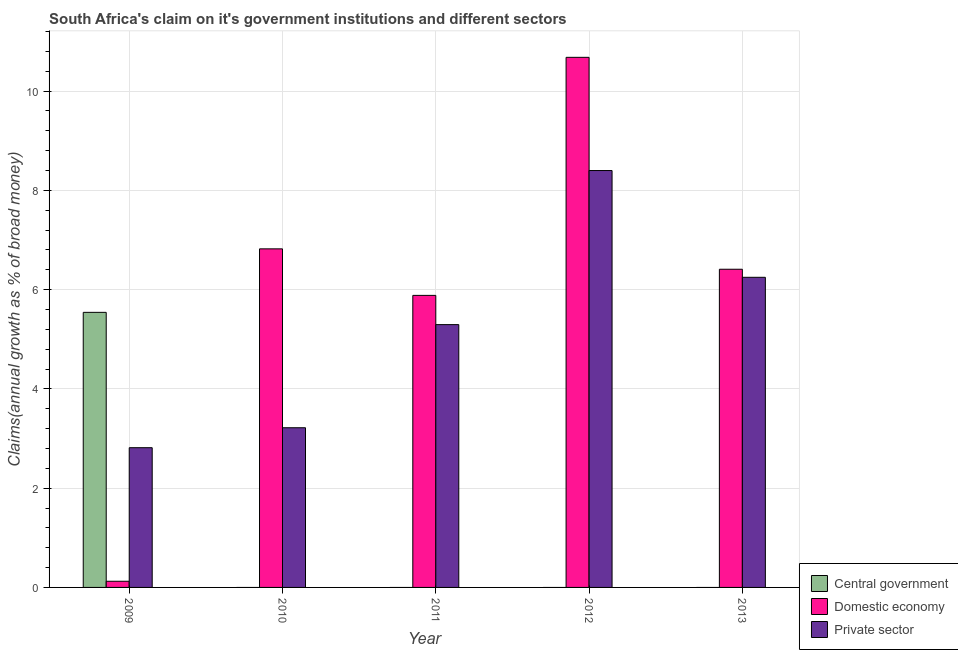How many groups of bars are there?
Your answer should be compact. 5. Are the number of bars per tick equal to the number of legend labels?
Keep it short and to the point. No. What is the label of the 5th group of bars from the left?
Keep it short and to the point. 2013. In how many cases, is the number of bars for a given year not equal to the number of legend labels?
Offer a terse response. 4. What is the percentage of claim on the domestic economy in 2012?
Keep it short and to the point. 10.68. Across all years, what is the maximum percentage of claim on the domestic economy?
Provide a succinct answer. 10.68. In which year was the percentage of claim on the private sector maximum?
Keep it short and to the point. 2012. What is the total percentage of claim on the private sector in the graph?
Offer a terse response. 25.97. What is the difference between the percentage of claim on the private sector in 2009 and that in 2012?
Your response must be concise. -5.58. What is the difference between the percentage of claim on the central government in 2013 and the percentage of claim on the domestic economy in 2009?
Provide a short and direct response. -5.54. What is the average percentage of claim on the private sector per year?
Provide a short and direct response. 5.19. In the year 2010, what is the difference between the percentage of claim on the domestic economy and percentage of claim on the private sector?
Ensure brevity in your answer.  0. What is the ratio of the percentage of claim on the private sector in 2010 to that in 2013?
Provide a succinct answer. 0.51. What is the difference between the highest and the second highest percentage of claim on the domestic economy?
Ensure brevity in your answer.  3.86. What is the difference between the highest and the lowest percentage of claim on the central government?
Provide a succinct answer. 5.54. Is it the case that in every year, the sum of the percentage of claim on the central government and percentage of claim on the domestic economy is greater than the percentage of claim on the private sector?
Keep it short and to the point. Yes. How many bars are there?
Keep it short and to the point. 11. How many years are there in the graph?
Your answer should be compact. 5. What is the difference between two consecutive major ticks on the Y-axis?
Your answer should be very brief. 2. Where does the legend appear in the graph?
Your answer should be very brief. Bottom right. How many legend labels are there?
Ensure brevity in your answer.  3. What is the title of the graph?
Keep it short and to the point. South Africa's claim on it's government institutions and different sectors. What is the label or title of the X-axis?
Your answer should be compact. Year. What is the label or title of the Y-axis?
Provide a short and direct response. Claims(annual growth as % of broad money). What is the Claims(annual growth as % of broad money) in Central government in 2009?
Keep it short and to the point. 5.54. What is the Claims(annual growth as % of broad money) in Domestic economy in 2009?
Offer a very short reply. 0.12. What is the Claims(annual growth as % of broad money) of Private sector in 2009?
Provide a short and direct response. 2.82. What is the Claims(annual growth as % of broad money) in Central government in 2010?
Make the answer very short. 0. What is the Claims(annual growth as % of broad money) of Domestic economy in 2010?
Provide a short and direct response. 6.82. What is the Claims(annual growth as % of broad money) in Private sector in 2010?
Your answer should be compact. 3.22. What is the Claims(annual growth as % of broad money) of Central government in 2011?
Provide a succinct answer. 0. What is the Claims(annual growth as % of broad money) of Domestic economy in 2011?
Ensure brevity in your answer.  5.88. What is the Claims(annual growth as % of broad money) in Private sector in 2011?
Your response must be concise. 5.29. What is the Claims(annual growth as % of broad money) of Central government in 2012?
Your response must be concise. 0. What is the Claims(annual growth as % of broad money) of Domestic economy in 2012?
Your answer should be compact. 10.68. What is the Claims(annual growth as % of broad money) of Private sector in 2012?
Offer a very short reply. 8.4. What is the Claims(annual growth as % of broad money) in Domestic economy in 2013?
Make the answer very short. 6.41. What is the Claims(annual growth as % of broad money) of Private sector in 2013?
Your answer should be compact. 6.25. Across all years, what is the maximum Claims(annual growth as % of broad money) in Central government?
Offer a very short reply. 5.54. Across all years, what is the maximum Claims(annual growth as % of broad money) in Domestic economy?
Your answer should be very brief. 10.68. Across all years, what is the maximum Claims(annual growth as % of broad money) in Private sector?
Your answer should be compact. 8.4. Across all years, what is the minimum Claims(annual growth as % of broad money) in Domestic economy?
Your response must be concise. 0.12. Across all years, what is the minimum Claims(annual growth as % of broad money) in Private sector?
Offer a terse response. 2.82. What is the total Claims(annual growth as % of broad money) in Central government in the graph?
Give a very brief answer. 5.54. What is the total Claims(annual growth as % of broad money) of Domestic economy in the graph?
Give a very brief answer. 29.92. What is the total Claims(annual growth as % of broad money) in Private sector in the graph?
Provide a succinct answer. 25.97. What is the difference between the Claims(annual growth as % of broad money) of Domestic economy in 2009 and that in 2010?
Ensure brevity in your answer.  -6.7. What is the difference between the Claims(annual growth as % of broad money) in Private sector in 2009 and that in 2010?
Provide a short and direct response. -0.4. What is the difference between the Claims(annual growth as % of broad money) in Domestic economy in 2009 and that in 2011?
Make the answer very short. -5.76. What is the difference between the Claims(annual growth as % of broad money) in Private sector in 2009 and that in 2011?
Make the answer very short. -2.48. What is the difference between the Claims(annual growth as % of broad money) of Domestic economy in 2009 and that in 2012?
Your response must be concise. -10.56. What is the difference between the Claims(annual growth as % of broad money) in Private sector in 2009 and that in 2012?
Your response must be concise. -5.58. What is the difference between the Claims(annual growth as % of broad money) in Domestic economy in 2009 and that in 2013?
Provide a succinct answer. -6.29. What is the difference between the Claims(annual growth as % of broad money) in Private sector in 2009 and that in 2013?
Give a very brief answer. -3.43. What is the difference between the Claims(annual growth as % of broad money) in Domestic economy in 2010 and that in 2011?
Your answer should be very brief. 0.94. What is the difference between the Claims(annual growth as % of broad money) in Private sector in 2010 and that in 2011?
Provide a short and direct response. -2.08. What is the difference between the Claims(annual growth as % of broad money) in Domestic economy in 2010 and that in 2012?
Give a very brief answer. -3.86. What is the difference between the Claims(annual growth as % of broad money) in Private sector in 2010 and that in 2012?
Make the answer very short. -5.18. What is the difference between the Claims(annual growth as % of broad money) in Domestic economy in 2010 and that in 2013?
Offer a very short reply. 0.41. What is the difference between the Claims(annual growth as % of broad money) in Private sector in 2010 and that in 2013?
Your answer should be compact. -3.03. What is the difference between the Claims(annual growth as % of broad money) in Domestic economy in 2011 and that in 2012?
Provide a short and direct response. -4.8. What is the difference between the Claims(annual growth as % of broad money) of Private sector in 2011 and that in 2012?
Offer a terse response. -3.1. What is the difference between the Claims(annual growth as % of broad money) in Domestic economy in 2011 and that in 2013?
Your answer should be compact. -0.53. What is the difference between the Claims(annual growth as % of broad money) of Private sector in 2011 and that in 2013?
Provide a succinct answer. -0.95. What is the difference between the Claims(annual growth as % of broad money) in Domestic economy in 2012 and that in 2013?
Your answer should be compact. 4.27. What is the difference between the Claims(annual growth as % of broad money) in Private sector in 2012 and that in 2013?
Provide a succinct answer. 2.15. What is the difference between the Claims(annual growth as % of broad money) in Central government in 2009 and the Claims(annual growth as % of broad money) in Domestic economy in 2010?
Give a very brief answer. -1.28. What is the difference between the Claims(annual growth as % of broad money) of Central government in 2009 and the Claims(annual growth as % of broad money) of Private sector in 2010?
Provide a succinct answer. 2.32. What is the difference between the Claims(annual growth as % of broad money) of Domestic economy in 2009 and the Claims(annual growth as % of broad money) of Private sector in 2010?
Give a very brief answer. -3.09. What is the difference between the Claims(annual growth as % of broad money) in Central government in 2009 and the Claims(annual growth as % of broad money) in Domestic economy in 2011?
Give a very brief answer. -0.34. What is the difference between the Claims(annual growth as % of broad money) in Central government in 2009 and the Claims(annual growth as % of broad money) in Private sector in 2011?
Give a very brief answer. 0.25. What is the difference between the Claims(annual growth as % of broad money) of Domestic economy in 2009 and the Claims(annual growth as % of broad money) of Private sector in 2011?
Provide a short and direct response. -5.17. What is the difference between the Claims(annual growth as % of broad money) of Central government in 2009 and the Claims(annual growth as % of broad money) of Domestic economy in 2012?
Make the answer very short. -5.14. What is the difference between the Claims(annual growth as % of broad money) of Central government in 2009 and the Claims(annual growth as % of broad money) of Private sector in 2012?
Your response must be concise. -2.86. What is the difference between the Claims(annual growth as % of broad money) in Domestic economy in 2009 and the Claims(annual growth as % of broad money) in Private sector in 2012?
Provide a succinct answer. -8.27. What is the difference between the Claims(annual growth as % of broad money) of Central government in 2009 and the Claims(annual growth as % of broad money) of Domestic economy in 2013?
Your response must be concise. -0.87. What is the difference between the Claims(annual growth as % of broad money) of Central government in 2009 and the Claims(annual growth as % of broad money) of Private sector in 2013?
Your response must be concise. -0.71. What is the difference between the Claims(annual growth as % of broad money) in Domestic economy in 2009 and the Claims(annual growth as % of broad money) in Private sector in 2013?
Offer a terse response. -6.12. What is the difference between the Claims(annual growth as % of broad money) in Domestic economy in 2010 and the Claims(annual growth as % of broad money) in Private sector in 2011?
Your response must be concise. 1.53. What is the difference between the Claims(annual growth as % of broad money) in Domestic economy in 2010 and the Claims(annual growth as % of broad money) in Private sector in 2012?
Give a very brief answer. -1.58. What is the difference between the Claims(annual growth as % of broad money) of Domestic economy in 2010 and the Claims(annual growth as % of broad money) of Private sector in 2013?
Ensure brevity in your answer.  0.57. What is the difference between the Claims(annual growth as % of broad money) in Domestic economy in 2011 and the Claims(annual growth as % of broad money) in Private sector in 2012?
Offer a terse response. -2.52. What is the difference between the Claims(annual growth as % of broad money) of Domestic economy in 2011 and the Claims(annual growth as % of broad money) of Private sector in 2013?
Offer a very short reply. -0.36. What is the difference between the Claims(annual growth as % of broad money) in Domestic economy in 2012 and the Claims(annual growth as % of broad money) in Private sector in 2013?
Provide a short and direct response. 4.43. What is the average Claims(annual growth as % of broad money) of Central government per year?
Your answer should be very brief. 1.11. What is the average Claims(annual growth as % of broad money) in Domestic economy per year?
Your answer should be compact. 5.98. What is the average Claims(annual growth as % of broad money) in Private sector per year?
Your answer should be compact. 5.19. In the year 2009, what is the difference between the Claims(annual growth as % of broad money) of Central government and Claims(annual growth as % of broad money) of Domestic economy?
Keep it short and to the point. 5.42. In the year 2009, what is the difference between the Claims(annual growth as % of broad money) of Central government and Claims(annual growth as % of broad money) of Private sector?
Offer a very short reply. 2.73. In the year 2009, what is the difference between the Claims(annual growth as % of broad money) in Domestic economy and Claims(annual growth as % of broad money) in Private sector?
Your answer should be compact. -2.69. In the year 2010, what is the difference between the Claims(annual growth as % of broad money) in Domestic economy and Claims(annual growth as % of broad money) in Private sector?
Keep it short and to the point. 3.6. In the year 2011, what is the difference between the Claims(annual growth as % of broad money) in Domestic economy and Claims(annual growth as % of broad money) in Private sector?
Your answer should be very brief. 0.59. In the year 2012, what is the difference between the Claims(annual growth as % of broad money) of Domestic economy and Claims(annual growth as % of broad money) of Private sector?
Your answer should be compact. 2.28. In the year 2013, what is the difference between the Claims(annual growth as % of broad money) in Domestic economy and Claims(annual growth as % of broad money) in Private sector?
Your response must be concise. 0.16. What is the ratio of the Claims(annual growth as % of broad money) of Domestic economy in 2009 to that in 2010?
Provide a short and direct response. 0.02. What is the ratio of the Claims(annual growth as % of broad money) in Private sector in 2009 to that in 2010?
Offer a very short reply. 0.88. What is the ratio of the Claims(annual growth as % of broad money) in Domestic economy in 2009 to that in 2011?
Offer a very short reply. 0.02. What is the ratio of the Claims(annual growth as % of broad money) of Private sector in 2009 to that in 2011?
Your response must be concise. 0.53. What is the ratio of the Claims(annual growth as % of broad money) of Domestic economy in 2009 to that in 2012?
Provide a succinct answer. 0.01. What is the ratio of the Claims(annual growth as % of broad money) in Private sector in 2009 to that in 2012?
Make the answer very short. 0.34. What is the ratio of the Claims(annual growth as % of broad money) of Domestic economy in 2009 to that in 2013?
Your answer should be compact. 0.02. What is the ratio of the Claims(annual growth as % of broad money) of Private sector in 2009 to that in 2013?
Your response must be concise. 0.45. What is the ratio of the Claims(annual growth as % of broad money) of Domestic economy in 2010 to that in 2011?
Provide a succinct answer. 1.16. What is the ratio of the Claims(annual growth as % of broad money) in Private sector in 2010 to that in 2011?
Your response must be concise. 0.61. What is the ratio of the Claims(annual growth as % of broad money) in Domestic economy in 2010 to that in 2012?
Provide a short and direct response. 0.64. What is the ratio of the Claims(annual growth as % of broad money) of Private sector in 2010 to that in 2012?
Ensure brevity in your answer.  0.38. What is the ratio of the Claims(annual growth as % of broad money) of Domestic economy in 2010 to that in 2013?
Your response must be concise. 1.06. What is the ratio of the Claims(annual growth as % of broad money) of Private sector in 2010 to that in 2013?
Offer a terse response. 0.51. What is the ratio of the Claims(annual growth as % of broad money) of Domestic economy in 2011 to that in 2012?
Provide a succinct answer. 0.55. What is the ratio of the Claims(annual growth as % of broad money) in Private sector in 2011 to that in 2012?
Provide a short and direct response. 0.63. What is the ratio of the Claims(annual growth as % of broad money) of Domestic economy in 2011 to that in 2013?
Your answer should be compact. 0.92. What is the ratio of the Claims(annual growth as % of broad money) in Private sector in 2011 to that in 2013?
Provide a succinct answer. 0.85. What is the ratio of the Claims(annual growth as % of broad money) in Domestic economy in 2012 to that in 2013?
Give a very brief answer. 1.67. What is the ratio of the Claims(annual growth as % of broad money) of Private sector in 2012 to that in 2013?
Your answer should be compact. 1.34. What is the difference between the highest and the second highest Claims(annual growth as % of broad money) in Domestic economy?
Offer a very short reply. 3.86. What is the difference between the highest and the second highest Claims(annual growth as % of broad money) in Private sector?
Keep it short and to the point. 2.15. What is the difference between the highest and the lowest Claims(annual growth as % of broad money) of Central government?
Offer a terse response. 5.54. What is the difference between the highest and the lowest Claims(annual growth as % of broad money) in Domestic economy?
Offer a terse response. 10.56. What is the difference between the highest and the lowest Claims(annual growth as % of broad money) in Private sector?
Your answer should be compact. 5.58. 